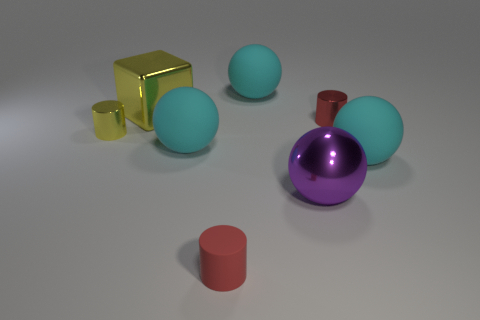What is the size of the red cylinder that is the same material as the big yellow thing?
Your answer should be very brief. Small. What number of other red metal objects are the same shape as the red shiny thing?
Offer a terse response. 0. Do the big sphere right of the purple metal thing and the tiny rubber cylinder have the same color?
Your answer should be very brief. No. How many large yellow cubes are behind the small cylinder that is behind the yellow metal thing in front of the big yellow shiny thing?
Ensure brevity in your answer.  1. How many cylinders are behind the big shiny ball and right of the large block?
Offer a terse response. 1. There is a metallic thing that is the same color as the tiny rubber cylinder; what shape is it?
Your answer should be compact. Cylinder. Do the large cube and the purple object have the same material?
Make the answer very short. Yes. The large cyan thing behind the large sphere to the left of the ball behind the small red metallic object is what shape?
Your response must be concise. Sphere. Is the number of tiny red matte things behind the small red shiny cylinder less than the number of yellow things that are to the left of the big yellow metallic cube?
Keep it short and to the point. Yes. There is a rubber object that is to the right of the large matte ball behind the large shiny cube; what is its shape?
Give a very brief answer. Sphere. 